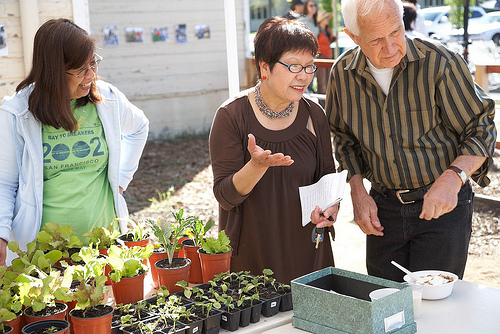<image>
Can you confirm if the woman is to the left of the man? No. The woman is not to the left of the man. From this viewpoint, they have a different horizontal relationship. 